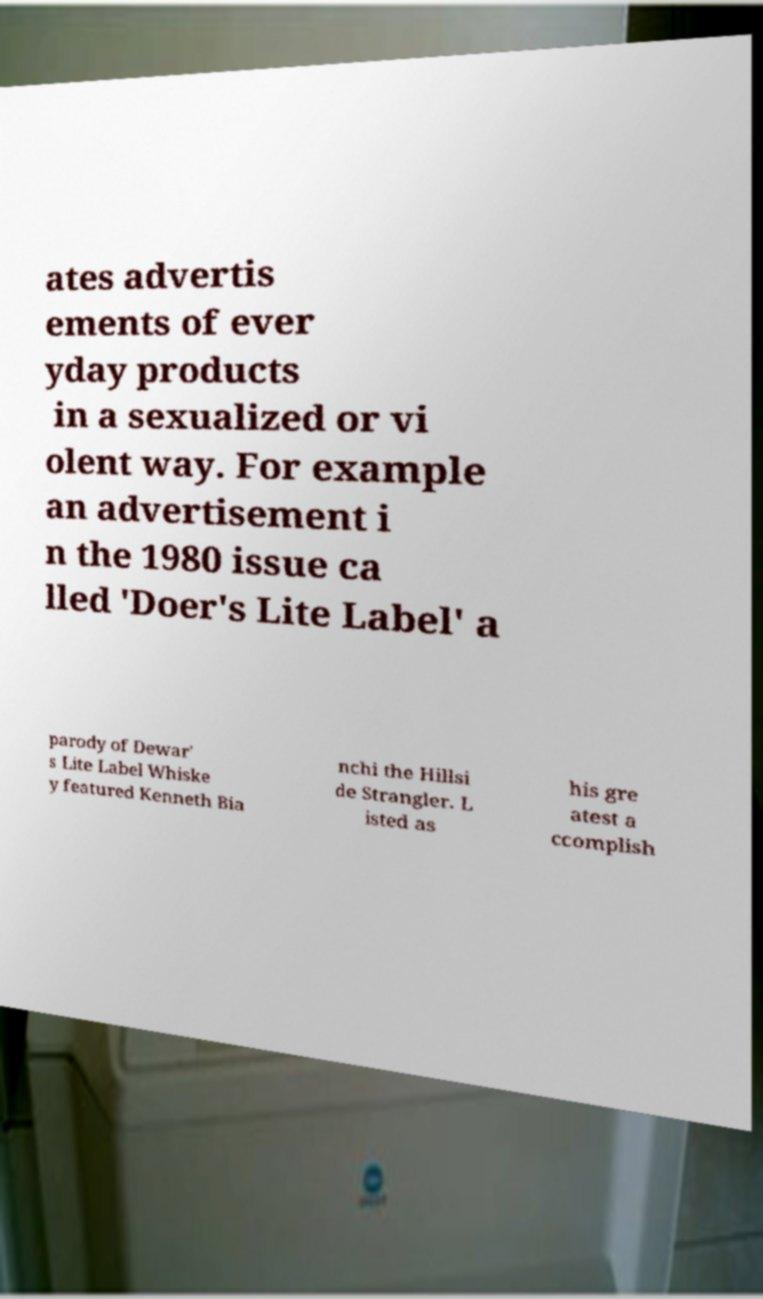Could you assist in decoding the text presented in this image and type it out clearly? ates advertis ements of ever yday products in a sexualized or vi olent way. For example an advertisement i n the 1980 issue ca lled 'Doer's Lite Label' a parody of Dewar' s Lite Label Whiske y featured Kenneth Bia nchi the Hillsi de Strangler. L isted as his gre atest a ccomplish 